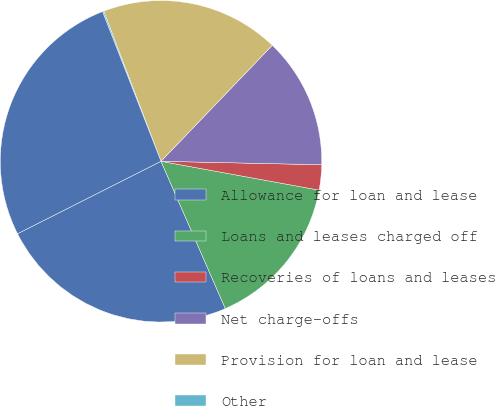Convert chart to OTSL. <chart><loc_0><loc_0><loc_500><loc_500><pie_chart><fcel>Allowance for loan and lease<fcel>Loans and leases charged off<fcel>Recoveries of loans and leases<fcel>Net charge-offs<fcel>Provision for loan and lease<fcel>Other<fcel>Allowance for credit losses<nl><fcel>24.11%<fcel>15.57%<fcel>2.53%<fcel>13.17%<fcel>17.97%<fcel>0.13%<fcel>26.51%<nl></chart> 